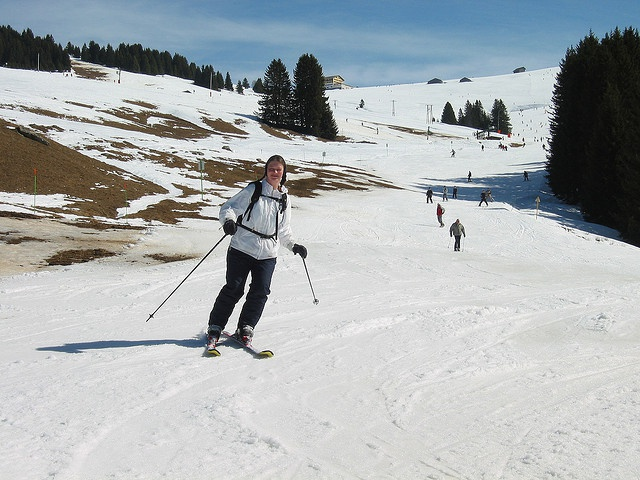Describe the objects in this image and their specific colors. I can see people in gray, black, darkgray, and lightgray tones, people in gray, lightgray, darkgray, and black tones, backpack in gray, black, and darkgray tones, skis in gray, black, lightgray, and darkgray tones, and people in gray, black, darkgray, and white tones in this image. 